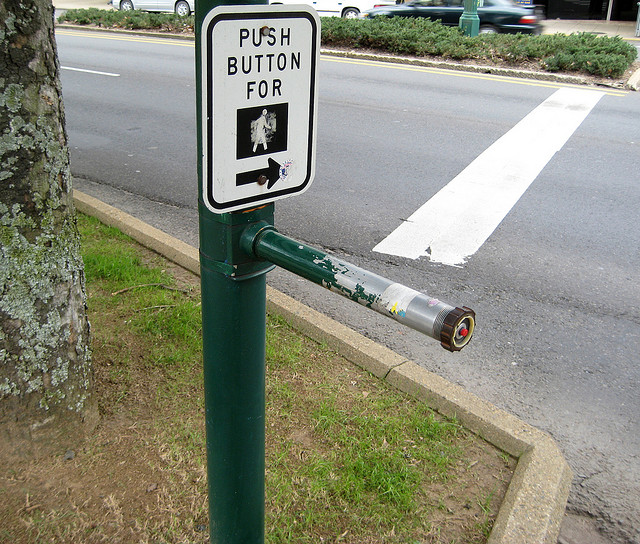Identify the text contained in this image. PUSH BUTTON FOR 